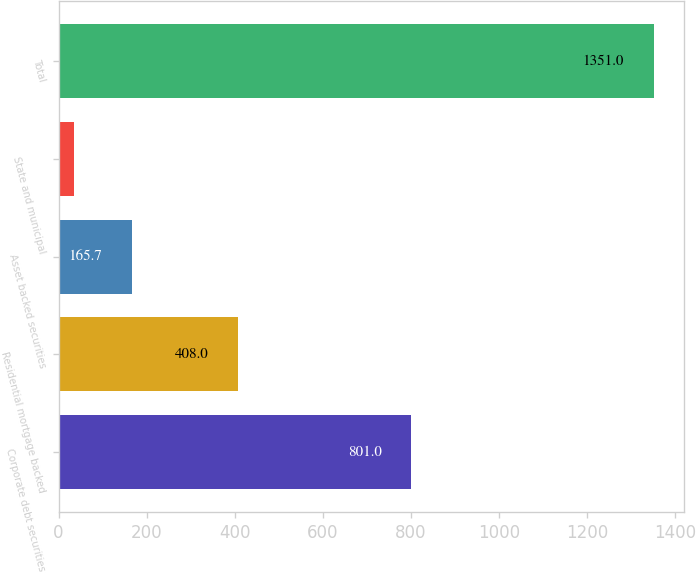Convert chart to OTSL. <chart><loc_0><loc_0><loc_500><loc_500><bar_chart><fcel>Corporate debt securities<fcel>Residential mortgage backed<fcel>Asset backed securities<fcel>State and municipal<fcel>Total<nl><fcel>801<fcel>408<fcel>165.7<fcel>34<fcel>1351<nl></chart> 